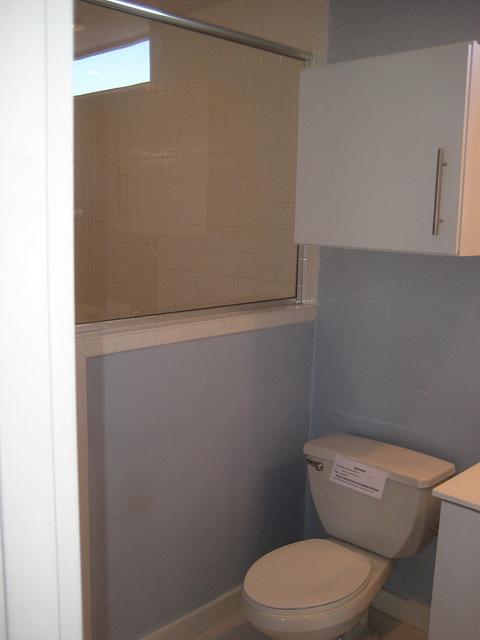Why is there a window above the toilet?
Be succinct. Ventilation. Is this bathroom functional?
Be succinct. Yes. What color is the white toilet?
Short answer required. White. What color are this bathrooms walls?
Short answer required. Blue. 